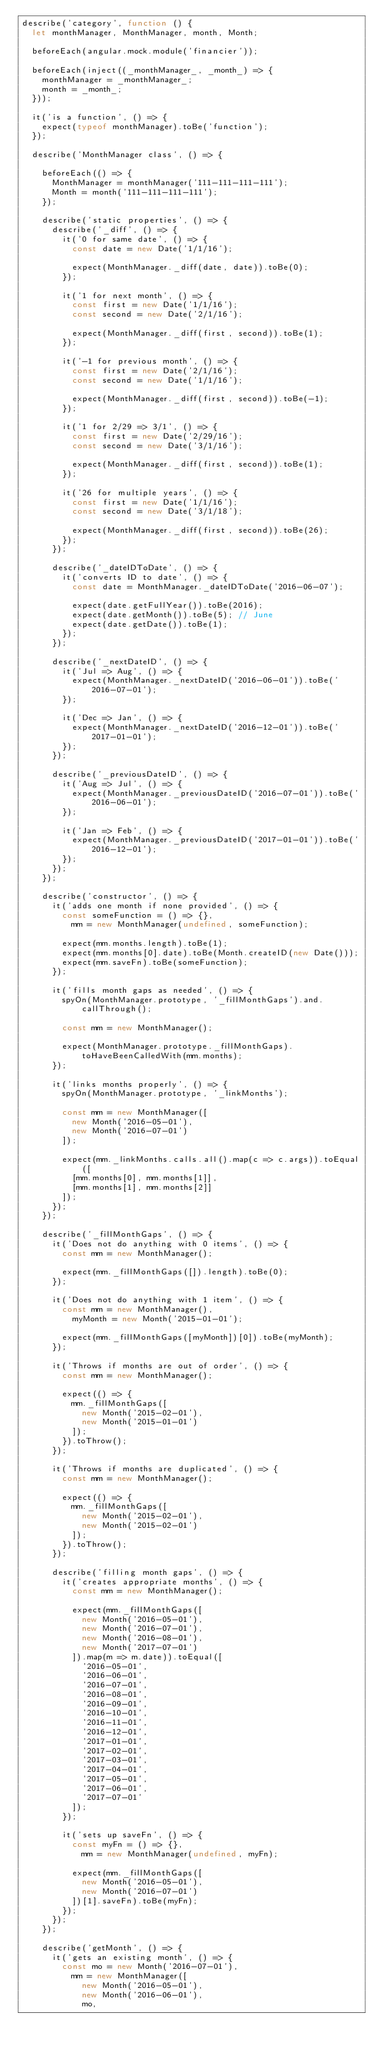<code> <loc_0><loc_0><loc_500><loc_500><_JavaScript_>describe('category', function () {
  let monthManager, MonthManager, month, Month;

  beforeEach(angular.mock.module('financier'));

  beforeEach(inject((_monthManager_, _month_) => {
    monthManager = _monthManager_;
    month = _month_;
  }));

  it('is a function', () => {
    expect(typeof monthManager).toBe('function');
  });

  describe('MonthManager class', () => {

    beforeEach(() => {
      MonthManager = monthManager('111-111-111-111');
      Month = month('111-111-111-111');
    });

    describe('static properties', () => {
      describe('_diff', () => {
        it('0 for same date', () => {
          const date = new Date('1/1/16');

          expect(MonthManager._diff(date, date)).toBe(0);
        });

        it('1 for next month', () => {
          const first = new Date('1/1/16');
          const second = new Date('2/1/16');

          expect(MonthManager._diff(first, second)).toBe(1);
        });

        it('-1 for previous month', () => {
          const first = new Date('2/1/16');
          const second = new Date('1/1/16');

          expect(MonthManager._diff(first, second)).toBe(-1);
        });

        it('1 for 2/29 => 3/1', () => {
          const first = new Date('2/29/16');
          const second = new Date('3/1/16');

          expect(MonthManager._diff(first, second)).toBe(1);
        });

        it('26 for multiple years', () => {
          const first = new Date('1/1/16');
          const second = new Date('3/1/18');

          expect(MonthManager._diff(first, second)).toBe(26);
        });
      });

      describe('_dateIDToDate', () => {
        it('converts ID to date', () => {
          const date = MonthManager._dateIDToDate('2016-06-07');

          expect(date.getFullYear()).toBe(2016);
          expect(date.getMonth()).toBe(5); // June
          expect(date.getDate()).toBe(1);
        });
      });

      describe('_nextDateID', () => {
        it('Jul => Aug', () => {
          expect(MonthManager._nextDateID('2016-06-01')).toBe('2016-07-01');
        });

        it('Dec => Jan', () => {
          expect(MonthManager._nextDateID('2016-12-01')).toBe('2017-01-01');
        });
      });

      describe('_previousDateID', () => {
        it('Aug => Jul', () => {
          expect(MonthManager._previousDateID('2016-07-01')).toBe('2016-06-01');
        });

        it('Jan => Feb', () => {
          expect(MonthManager._previousDateID('2017-01-01')).toBe('2016-12-01');
        });
      });
    });

    describe('constructor', () => {
      it('adds one month if none provided', () => {
        const someFunction = () => {},
          mm = new MonthManager(undefined, someFunction);

        expect(mm.months.length).toBe(1);
        expect(mm.months[0].date).toBe(Month.createID(new Date()));
        expect(mm.saveFn).toBe(someFunction);
      });

      it('fills month gaps as needed', () => {
        spyOn(MonthManager.prototype, '_fillMonthGaps').and.callThrough();

        const mm = new MonthManager();

        expect(MonthManager.prototype._fillMonthGaps).toHaveBeenCalledWith(mm.months);
      });

      it('links months properly', () => {
        spyOn(MonthManager.prototype, '_linkMonths');

        const mm = new MonthManager([
          new Month('2016-05-01'),
          new Month('2016-07-01')
        ]);

        expect(mm._linkMonths.calls.all().map(c => c.args)).toEqual([
          [mm.months[0], mm.months[1]],
          [mm.months[1], mm.months[2]]
        ]);
      });
    });

    describe('_fillMonthGaps', () => {
      it('Does not do anything with 0 items', () => {
        const mm = new MonthManager();

        expect(mm._fillMonthGaps([]).length).toBe(0);
      });

      it('Does not do anything with 1 item', () => {
        const mm = new MonthManager(),
          myMonth = new Month('2015-01-01');

        expect(mm._fillMonthGaps([myMonth])[0]).toBe(myMonth);
      });

      it('Throws if months are out of order', () => {
        const mm = new MonthManager();

        expect(() => {
          mm._fillMonthGaps([
            new Month('2015-02-01'),
            new Month('2015-01-01')
          ]);
        }).toThrow();
      });

      it('Throws if months are duplicated', () => {
        const mm = new MonthManager();

        expect(() => {
          mm._fillMonthGaps([
            new Month('2015-02-01'),
            new Month('2015-02-01')
          ]);
        }).toThrow();
      });

      describe('filling month gaps', () => {
        it('creates appropriate months', () => {
          const mm = new MonthManager();

          expect(mm._fillMonthGaps([
            new Month('2016-05-01'),
            new Month('2016-07-01'),
            new Month('2016-08-01'),
            new Month('2017-07-01')
          ]).map(m => m.date)).toEqual([
            '2016-05-01',
            '2016-06-01',
            '2016-07-01',
            '2016-08-01',
            '2016-09-01',
            '2016-10-01',
            '2016-11-01',
            '2016-12-01',
            '2017-01-01',
            '2017-02-01',
            '2017-03-01',
            '2017-04-01',
            '2017-05-01',
            '2017-06-01',
            '2017-07-01'
          ]);
        });

        it('sets up saveFn', () => {
          const myFn = () => {},
            mm = new MonthManager(undefined, myFn);

          expect(mm._fillMonthGaps([
            new Month('2016-05-01'),
            new Month('2016-07-01')
          ])[1].saveFn).toBe(myFn);
        });
      });
    });

    describe('getMonth', () => {
      it('gets an existing month', () => {
        const mo = new Month('2016-07-01'),
          mm = new MonthManager([
            new Month('2016-05-01'),
            new Month('2016-06-01'),
            mo,</code> 